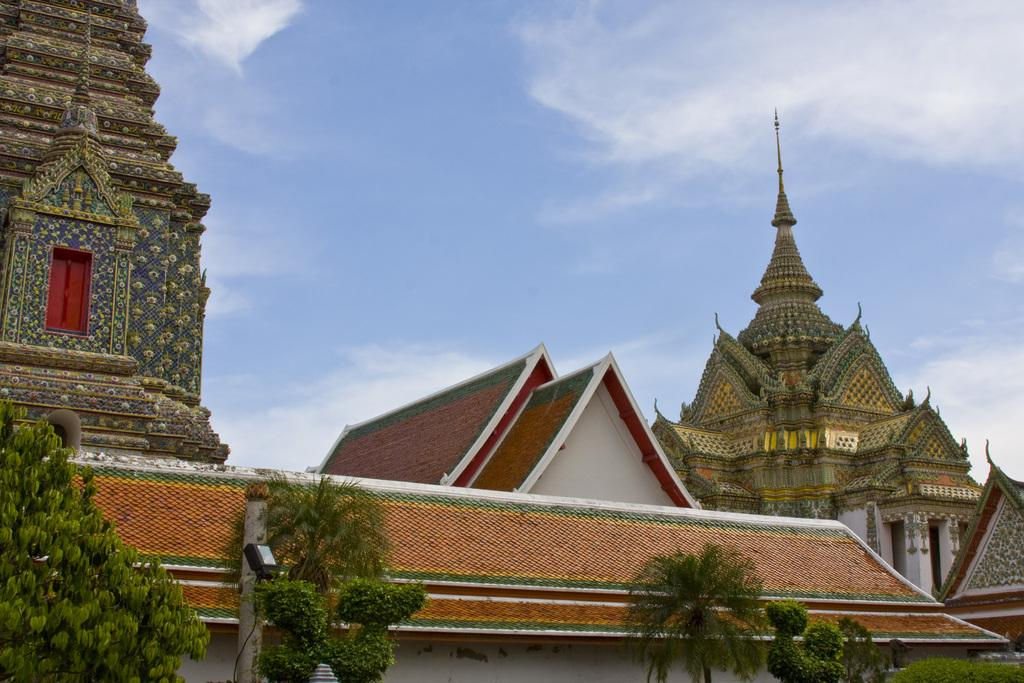What type of structures can be seen in the image? There are buildings in the image. What other natural elements are present in the image? There are trees in the image. What can be seen in the background of the image? The sky is visible in the background of the image. How would you describe the weather based on the appearance of the sky? The sky appears to be cloudy in the image. What type of insect can be seen flying around the buildings in the image? There are no insects visible in the image; it only shows buildings, trees, and a cloudy sky. 